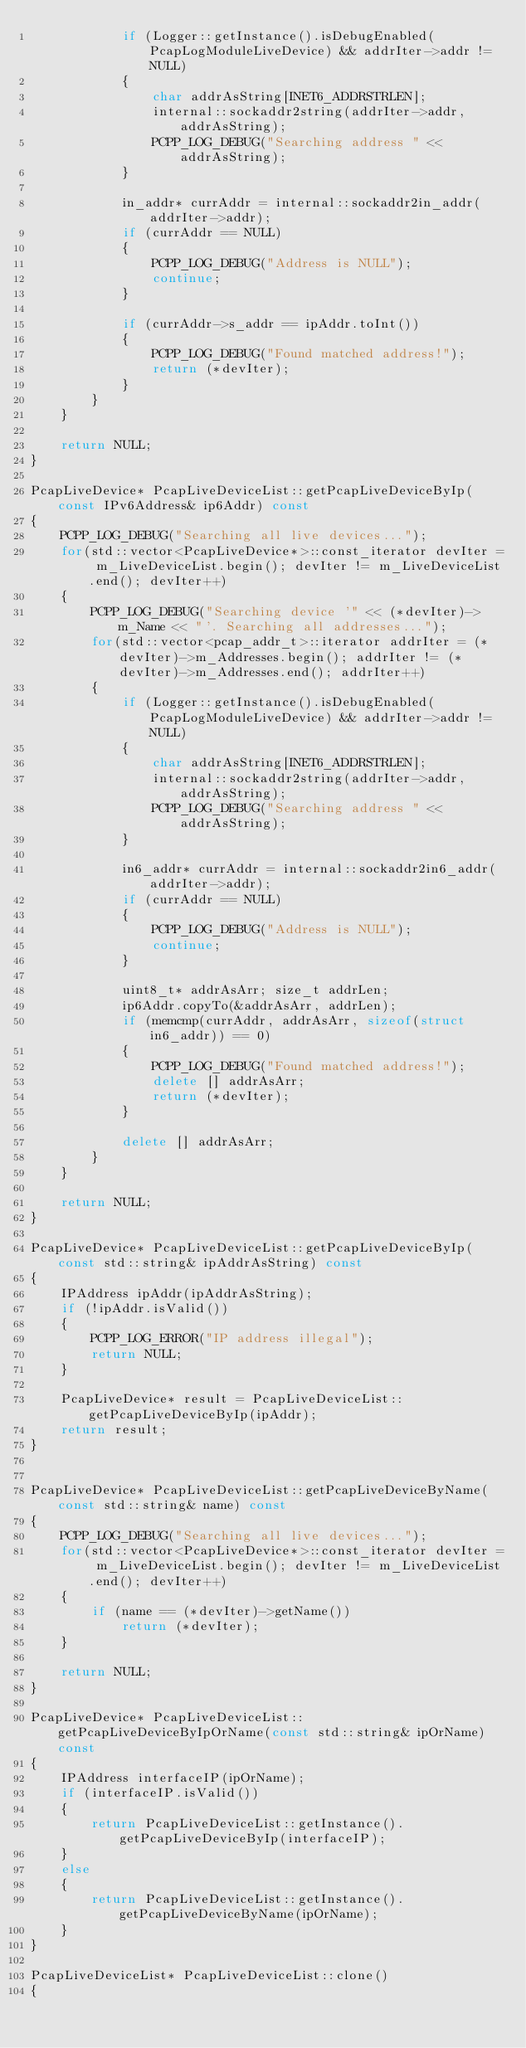Convert code to text. <code><loc_0><loc_0><loc_500><loc_500><_C++_>			if (Logger::getInstance().isDebugEnabled(PcapLogModuleLiveDevice) && addrIter->addr != NULL)
			{
				char addrAsString[INET6_ADDRSTRLEN];
				internal::sockaddr2string(addrIter->addr, addrAsString);
				PCPP_LOG_DEBUG("Searching address " << addrAsString);
			}

			in_addr* currAddr = internal::sockaddr2in_addr(addrIter->addr);
			if (currAddr == NULL)
			{
				PCPP_LOG_DEBUG("Address is NULL");
				continue;
			}

			if (currAddr->s_addr == ipAddr.toInt())
			{
				PCPP_LOG_DEBUG("Found matched address!");
				return (*devIter);
			}
		}
	}

	return NULL;
}

PcapLiveDevice* PcapLiveDeviceList::getPcapLiveDeviceByIp(const IPv6Address& ip6Addr) const
{
	PCPP_LOG_DEBUG("Searching all live devices...");
	for(std::vector<PcapLiveDevice*>::const_iterator devIter = m_LiveDeviceList.begin(); devIter != m_LiveDeviceList.end(); devIter++)
	{
		PCPP_LOG_DEBUG("Searching device '" << (*devIter)->m_Name << "'. Searching all addresses...");
		for(std::vector<pcap_addr_t>::iterator addrIter = (*devIter)->m_Addresses.begin(); addrIter != (*devIter)->m_Addresses.end(); addrIter++)
		{
			if (Logger::getInstance().isDebugEnabled(PcapLogModuleLiveDevice) && addrIter->addr != NULL)
			{
				char addrAsString[INET6_ADDRSTRLEN];
				internal::sockaddr2string(addrIter->addr, addrAsString);
				PCPP_LOG_DEBUG("Searching address " << addrAsString);
			}

			in6_addr* currAddr = internal::sockaddr2in6_addr(addrIter->addr);
			if (currAddr == NULL)
			{
				PCPP_LOG_DEBUG("Address is NULL");
				continue;
			}

			uint8_t* addrAsArr; size_t addrLen;
			ip6Addr.copyTo(&addrAsArr, addrLen);
			if (memcmp(currAddr, addrAsArr, sizeof(struct in6_addr)) == 0)
			{
				PCPP_LOG_DEBUG("Found matched address!");
				delete [] addrAsArr;
				return (*devIter);
			}

			delete [] addrAsArr;
		}
	}

	return NULL;
}

PcapLiveDevice* PcapLiveDeviceList::getPcapLiveDeviceByIp(const std::string& ipAddrAsString) const
{
	IPAddress ipAddr(ipAddrAsString);
	if (!ipAddr.isValid())
	{
		PCPP_LOG_ERROR("IP address illegal");
		return NULL;
	}

	PcapLiveDevice* result = PcapLiveDeviceList::getPcapLiveDeviceByIp(ipAddr);
	return result;
}


PcapLiveDevice* PcapLiveDeviceList::getPcapLiveDeviceByName(const std::string& name) const
{
	PCPP_LOG_DEBUG("Searching all live devices...");
	for(std::vector<PcapLiveDevice*>::const_iterator devIter = m_LiveDeviceList.begin(); devIter != m_LiveDeviceList.end(); devIter++)
	{
		if (name == (*devIter)->getName())
			return (*devIter);
	}

	return NULL;
}

PcapLiveDevice* PcapLiveDeviceList::getPcapLiveDeviceByIpOrName(const std::string& ipOrName) const
{
	IPAddress interfaceIP(ipOrName);
	if (interfaceIP.isValid())
	{
		return PcapLiveDeviceList::getInstance().getPcapLiveDeviceByIp(interfaceIP);
	}
	else
	{
		return PcapLiveDeviceList::getInstance().getPcapLiveDeviceByName(ipOrName);
	}
}

PcapLiveDeviceList* PcapLiveDeviceList::clone()
{</code> 